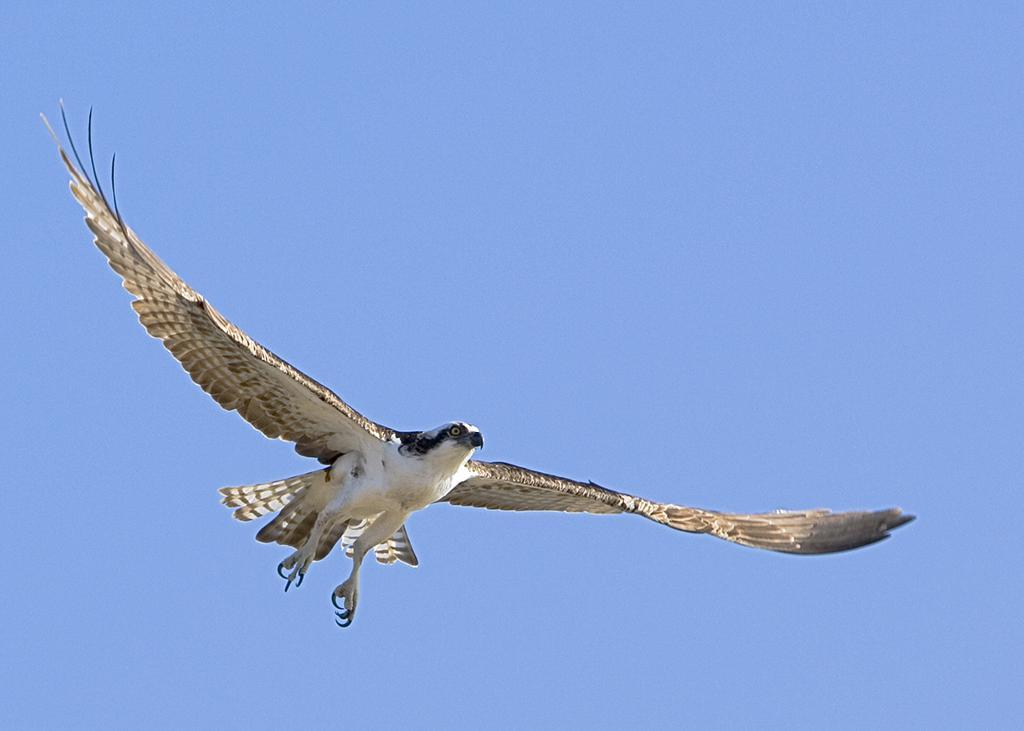What animal is present in the image? There is an eagle in the image. What is the eagle doing in the image? The eagle is flying in the image. What can be seen in the background of the image? The sky is visible in the background of the image. Can you see a stranger in the wilderness in the image? There is no stranger or wilderness present in the image; it features an eagle flying in the sky. Is there a tub visible in the image? There is no tub present in the image. 